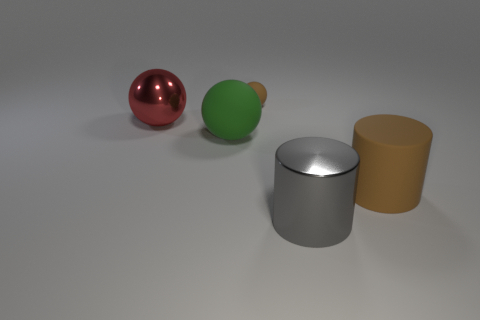Does the tiny sphere have the same color as the large rubber object right of the green thing?
Offer a very short reply. Yes. What is the size of the cylinder that is the same color as the small object?
Give a very brief answer. Large. Is the big matte cylinder the same color as the tiny thing?
Ensure brevity in your answer.  Yes. What color is the large rubber thing that is left of the big brown cylinder?
Your answer should be very brief. Green. The big green thing has what shape?
Provide a short and direct response. Sphere. There is a large cylinder that is to the left of the large rubber thing in front of the large matte sphere; is there a brown cylinder in front of it?
Offer a very short reply. No. There is a rubber sphere that is in front of the metal object that is behind the metallic object that is right of the small brown thing; what is its color?
Your response must be concise. Green. There is a big brown object that is the same shape as the gray thing; what is its material?
Your answer should be very brief. Rubber. What size is the matte ball that is in front of the brown thing that is to the left of the large brown cylinder?
Your answer should be compact. Large. There is a sphere that is to the left of the big green matte object; what material is it?
Keep it short and to the point. Metal. 